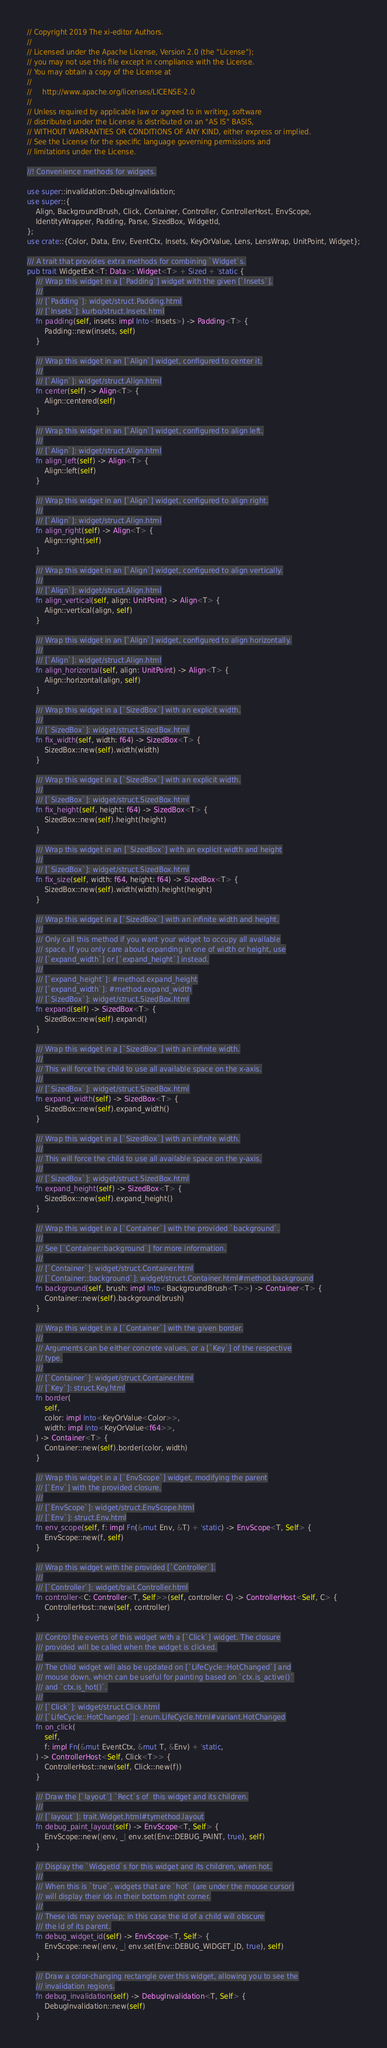<code> <loc_0><loc_0><loc_500><loc_500><_Rust_>// Copyright 2019 The xi-editor Authors.
//
// Licensed under the Apache License, Version 2.0 (the "License");
// you may not use this file except in compliance with the License.
// You may obtain a copy of the License at
//
//     http://www.apache.org/licenses/LICENSE-2.0
//
// Unless required by applicable law or agreed to in writing, software
// distributed under the License is distributed on an "AS IS" BASIS,
// WITHOUT WARRANTIES OR CONDITIONS OF ANY KIND, either express or implied.
// See the License for the specific language governing permissions and
// limitations under the License.

//! Convenience methods for widgets.

use super::invalidation::DebugInvalidation;
use super::{
    Align, BackgroundBrush, Click, Container, Controller, ControllerHost, EnvScope,
    IdentityWrapper, Padding, Parse, SizedBox, WidgetId,
};
use crate::{Color, Data, Env, EventCtx, Insets, KeyOrValue, Lens, LensWrap, UnitPoint, Widget};

/// A trait that provides extra methods for combining `Widget`s.
pub trait WidgetExt<T: Data>: Widget<T> + Sized + 'static {
    /// Wrap this widget in a [`Padding`] widget with the given [`Insets`].
    ///
    /// [`Padding`]: widget/struct.Padding.html
    /// [`Insets`]: kurbo/struct.Insets.html
    fn padding(self, insets: impl Into<Insets>) -> Padding<T> {
        Padding::new(insets, self)
    }

    /// Wrap this widget in an [`Align`] widget, configured to center it.
    ///
    /// [`Align`]: widget/struct.Align.html
    fn center(self) -> Align<T> {
        Align::centered(self)
    }

    /// Wrap this widget in an [`Align`] widget, configured to align left.
    ///
    /// [`Align`]: widget/struct.Align.html
    fn align_left(self) -> Align<T> {
        Align::left(self)
    }

    /// Wrap this widget in an [`Align`] widget, configured to align right.
    ///
    /// [`Align`]: widget/struct.Align.html
    fn align_right(self) -> Align<T> {
        Align::right(self)
    }

    /// Wrap this widget in an [`Align`] widget, configured to align vertically.
    ///
    /// [`Align`]: widget/struct.Align.html
    fn align_vertical(self, align: UnitPoint) -> Align<T> {
        Align::vertical(align, self)
    }

    /// Wrap this widget in an [`Align`] widget, configured to align horizontally.
    ///
    /// [`Align`]: widget/struct.Align.html
    fn align_horizontal(self, align: UnitPoint) -> Align<T> {
        Align::horizontal(align, self)
    }

    /// Wrap this widget in a [`SizedBox`] with an explicit width.
    ///
    /// [`SizedBox`]: widget/struct.SizedBox.html
    fn fix_width(self, width: f64) -> SizedBox<T> {
        SizedBox::new(self).width(width)
    }

    /// Wrap this widget in a [`SizedBox`] with an explicit width.
    ///
    /// [`SizedBox`]: widget/struct.SizedBox.html
    fn fix_height(self, height: f64) -> SizedBox<T> {
        SizedBox::new(self).height(height)
    }

    /// Wrap this widget in an [`SizedBox`] with an explicit width and height
    ///
    /// [`SizedBox`]: widget/struct.SizedBox.html
    fn fix_size(self, width: f64, height: f64) -> SizedBox<T> {
        SizedBox::new(self).width(width).height(height)
    }

    /// Wrap this widget in a [`SizedBox`] with an infinite width and height.
    ///
    /// Only call this method if you want your widget to occupy all available
    /// space. If you only care about expanding in one of width or height, use
    /// [`expand_width`] or [`expand_height`] instead.
    ///
    /// [`expand_height`]: #method.expand_height
    /// [`expand_width`]: #method.expand_width
    /// [`SizedBox`]: widget/struct.SizedBox.html
    fn expand(self) -> SizedBox<T> {
        SizedBox::new(self).expand()
    }

    /// Wrap this widget in a [`SizedBox`] with an infinite width.
    ///
    /// This will force the child to use all available space on the x-axis.
    ///
    /// [`SizedBox`]: widget/struct.SizedBox.html
    fn expand_width(self) -> SizedBox<T> {
        SizedBox::new(self).expand_width()
    }

    /// Wrap this widget in a [`SizedBox`] with an infinite width.
    ///
    /// This will force the child to use all available space on the y-axis.
    ///
    /// [`SizedBox`]: widget/struct.SizedBox.html
    fn expand_height(self) -> SizedBox<T> {
        SizedBox::new(self).expand_height()
    }

    /// Wrap this widget in a [`Container`] with the provided `background`.
    ///
    /// See [`Container::background`] for more information.
    ///
    /// [`Container`]: widget/struct.Container.html
    /// [`Container::background`]: widget/struct.Container.html#method.background
    fn background(self, brush: impl Into<BackgroundBrush<T>>) -> Container<T> {
        Container::new(self).background(brush)
    }

    /// Wrap this widget in a [`Container`] with the given border.
    ///
    /// Arguments can be either concrete values, or a [`Key`] of the respective
    /// type.
    ///
    /// [`Container`]: widget/struct.Container.html
    /// [`Key`]: struct.Key.html
    fn border(
        self,
        color: impl Into<KeyOrValue<Color>>,
        width: impl Into<KeyOrValue<f64>>,
    ) -> Container<T> {
        Container::new(self).border(color, width)
    }

    /// Wrap this widget in a [`EnvScope`] widget, modifying the parent
    /// [`Env`] with the provided closure.
    ///
    /// [`EnvScope`]: widget/struct.EnvScope.html
    /// [`Env`]: struct.Env.html
    fn env_scope(self, f: impl Fn(&mut Env, &T) + 'static) -> EnvScope<T, Self> {
        EnvScope::new(f, self)
    }

    /// Wrap this widget with the provided [`Controller`].
    ///
    /// [`Controller`]: widget/trait.Controller.html
    fn controller<C: Controller<T, Self>>(self, controller: C) -> ControllerHost<Self, C> {
        ControllerHost::new(self, controller)
    }

    /// Control the events of this widget with a [`Click`] widget. The closure
    /// provided will be called when the widget is clicked.
    ///
    /// The child widget will also be updated on [`LifeCycle::HotChanged`] and
    /// mouse down, which can be useful for painting based on `ctx.is_active()`
    /// and `ctx.is_hot()`.
    ///
    /// [`Click`]: widget/struct.Click.html
    /// [`LifeCycle::HotChanged`]: enum.LifeCycle.html#variant.HotChanged
    fn on_click(
        self,
        f: impl Fn(&mut EventCtx, &mut T, &Env) + 'static,
    ) -> ControllerHost<Self, Click<T>> {
        ControllerHost::new(self, Click::new(f))
    }

    /// Draw the [`layout`] `Rect`s of  this widget and its children.
    ///
    /// [`layout`]: trait.Widget.html#tymethod.layout
    fn debug_paint_layout(self) -> EnvScope<T, Self> {
        EnvScope::new(|env, _| env.set(Env::DEBUG_PAINT, true), self)
    }

    /// Display the `WidgetId`s for this widget and its children, when hot.
    ///
    /// When this is `true`, widgets that are `hot` (are under the mouse cursor)
    /// will display their ids in their bottom right corner.
    ///
    /// These ids may overlap; in this case the id of a child will obscure
    /// the id of its parent.
    fn debug_widget_id(self) -> EnvScope<T, Self> {
        EnvScope::new(|env, _| env.set(Env::DEBUG_WIDGET_ID, true), self)
    }

    /// Draw a color-changing rectangle over this widget, allowing you to see the
    /// invalidation regions.
    fn debug_invalidation(self) -> DebugInvalidation<T, Self> {
        DebugInvalidation::new(self)
    }
</code> 